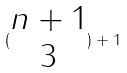<formula> <loc_0><loc_0><loc_500><loc_500>( \begin{matrix} n + 1 \\ 3 \end{matrix} ) + 1</formula> 